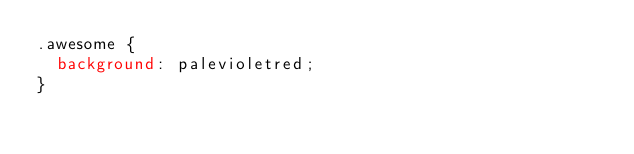Convert code to text. <code><loc_0><loc_0><loc_500><loc_500><_CSS_>.awesome {
  background: palevioletred;
}</code> 